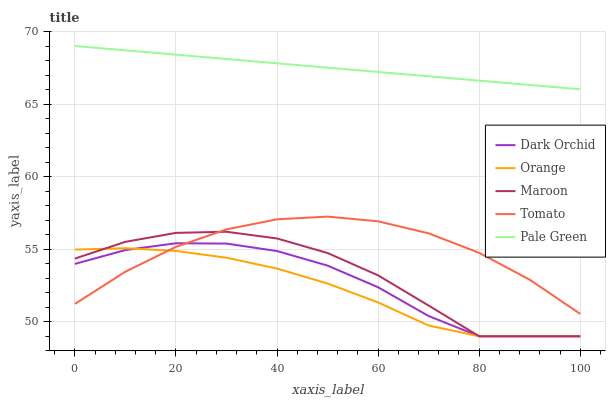Does Orange have the minimum area under the curve?
Answer yes or no. Yes. Does Pale Green have the maximum area under the curve?
Answer yes or no. Yes. Does Tomato have the minimum area under the curve?
Answer yes or no. No. Does Tomato have the maximum area under the curve?
Answer yes or no. No. Is Pale Green the smoothest?
Answer yes or no. Yes. Is Maroon the roughest?
Answer yes or no. Yes. Is Tomato the smoothest?
Answer yes or no. No. Is Tomato the roughest?
Answer yes or no. No. Does Tomato have the lowest value?
Answer yes or no. No. Does Pale Green have the highest value?
Answer yes or no. Yes. Does Tomato have the highest value?
Answer yes or no. No. Is Maroon less than Pale Green?
Answer yes or no. Yes. Is Pale Green greater than Tomato?
Answer yes or no. Yes. Does Tomato intersect Orange?
Answer yes or no. Yes. Is Tomato less than Orange?
Answer yes or no. No. Is Tomato greater than Orange?
Answer yes or no. No. Does Maroon intersect Pale Green?
Answer yes or no. No. 